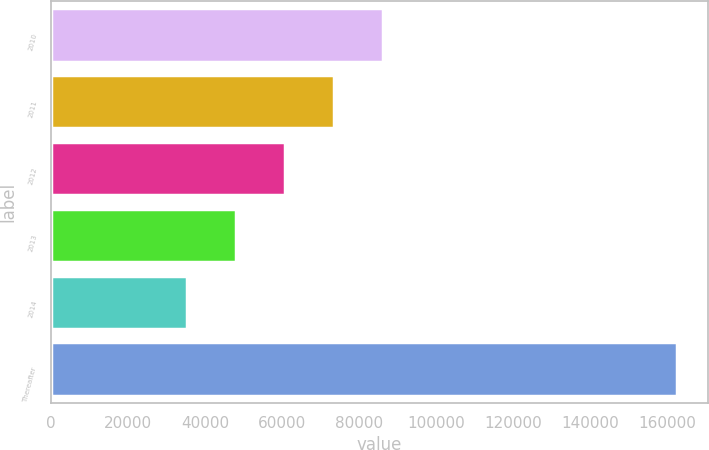Convert chart to OTSL. <chart><loc_0><loc_0><loc_500><loc_500><bar_chart><fcel>2010<fcel>2011<fcel>2012<fcel>2013<fcel>2014<fcel>Thereafter<nl><fcel>86335.8<fcel>73616.1<fcel>60896.4<fcel>48176.7<fcel>35457<fcel>162654<nl></chart> 